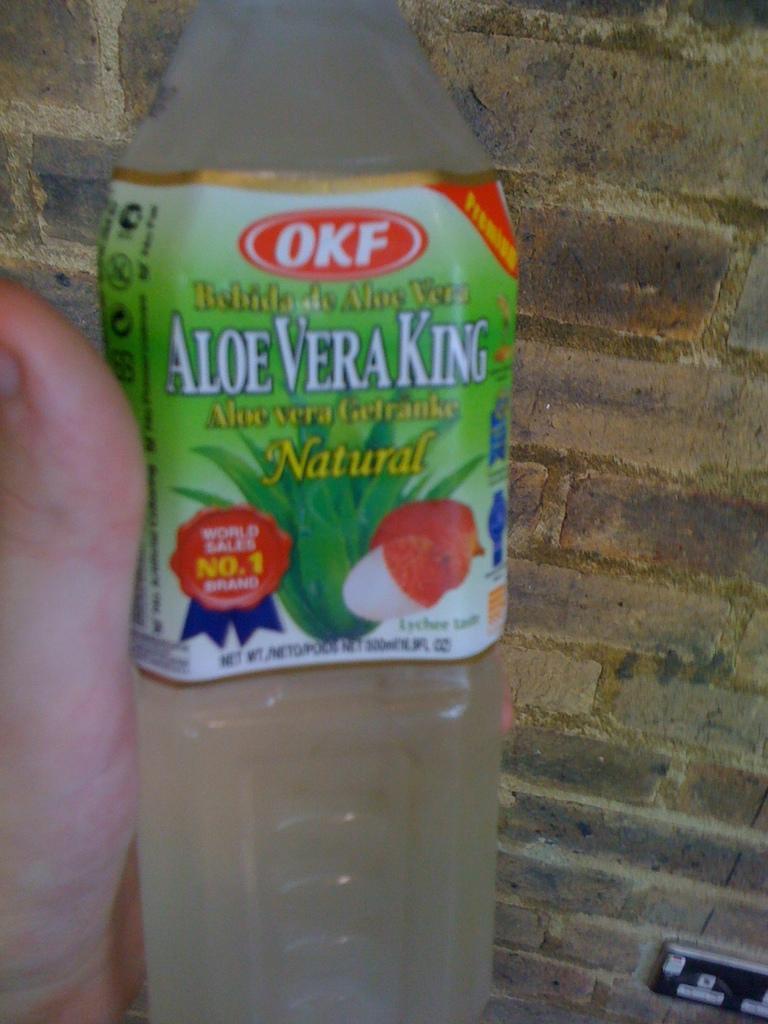Describe this image in one or two sentences. In this image we can see a person's hand holding plastic water bottle. In the background we can see wall. 